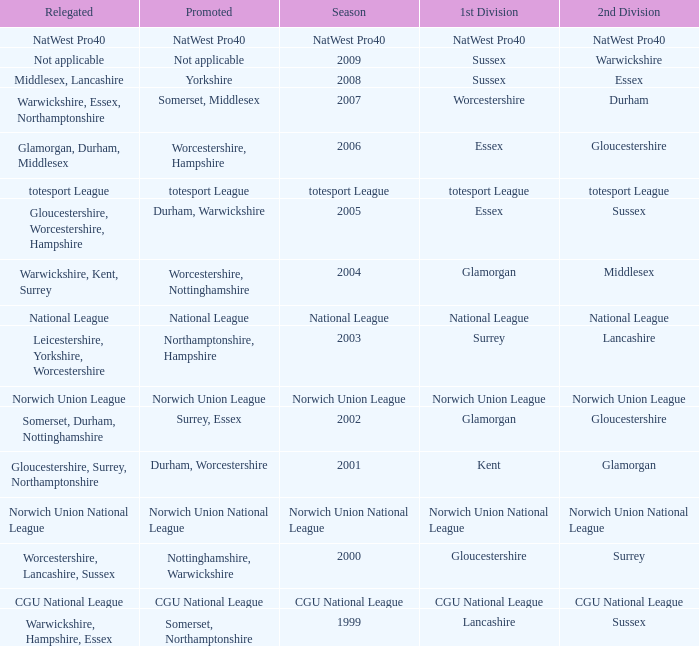What is the 1st division when the 2nd division is national league? National League. 